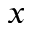<formula> <loc_0><loc_0><loc_500><loc_500>x</formula> 